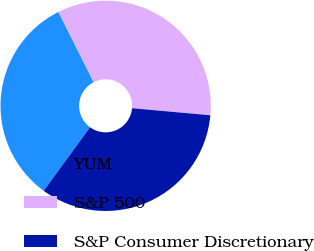Convert chart to OTSL. <chart><loc_0><loc_0><loc_500><loc_500><pie_chart><fcel>YUM<fcel>S&P 500<fcel>S&P Consumer Discretionary<nl><fcel>32.55%<fcel>33.86%<fcel>33.6%<nl></chart> 